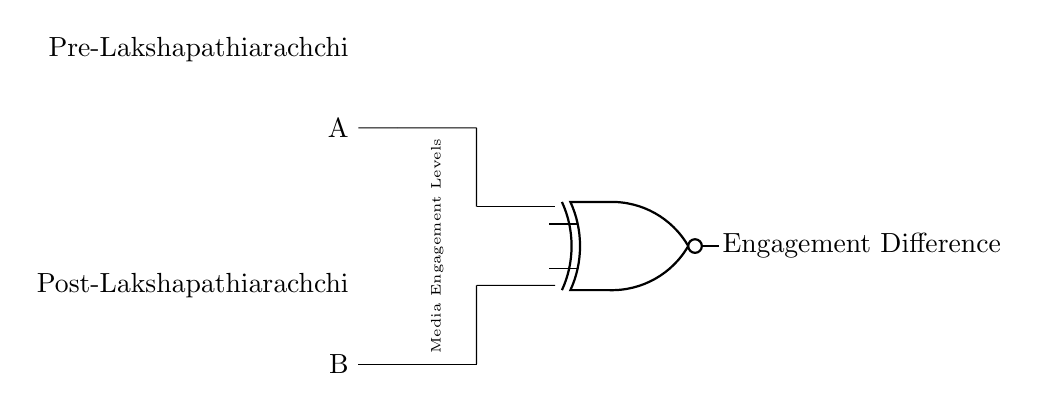What are the inputs of this circuit? The circuit has two inputs labeled A and B, which represent media engagement levels before and after Lakshapathiarachchi's influence, respectively.
Answer: A and B What type of logic gate is shown in the circuit? The circuit shows an XNOR gate, which is indicated by the XNOR port symbol in the diagram. This gate will output a true value (1) when both inputs are equal.
Answer: XNOR What does this circuit output when A equals B? The output of an XNOR gate is true (1) when both inputs are equal. Thus, if A equals B (both high or both low engagement), the output would be 1.
Answer: 1 What is the purpose of the comparator in this circuit? The comparator (XNOR gate) is used to determine if the media engagement levels before and after Lakshapathiarachchi's influence are the same or different, thereby indicating the difference in engagement levels.
Answer: To compare engagement levels What is indicated by the label "Engagement Difference"? The label "Engagement Difference" indicates the output result of the XNOR gate, showing whether the media engagement levels have changed or remained the same after Lakshapathiarachchi's influence.
Answer: Engagement status What happens to the output when A is high and B is low? When A is high (1) and B is low (0), the XNOR gate will output false (0), since the inputs are not equal.
Answer: 0 What does it mean if the output of the circuit is false? A false (0) output indicates that the media engagement levels before and after Lakshapathiarachchi's influence are different, suggesting a change in engagement.
Answer: Different engagement levels 